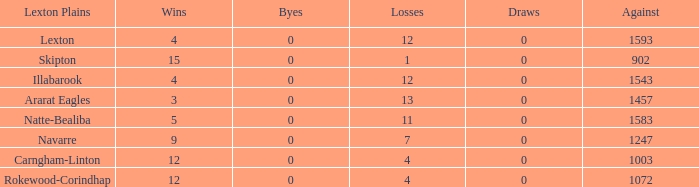What is the most wins with 0 byes? None. 